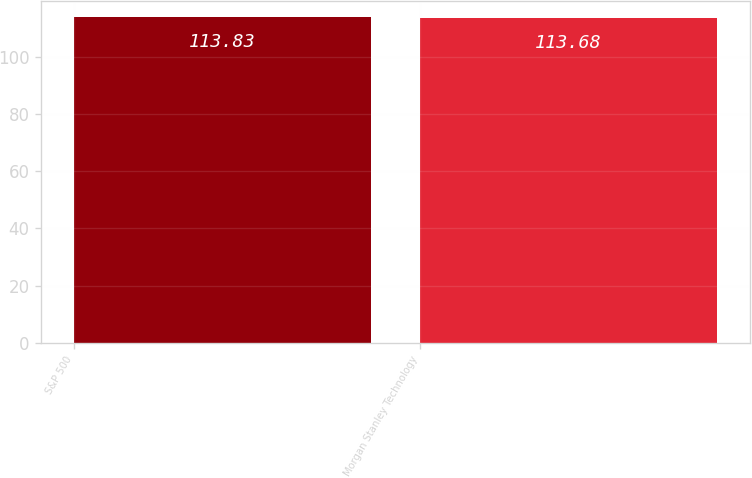<chart> <loc_0><loc_0><loc_500><loc_500><bar_chart><fcel>S&P 500<fcel>Morgan Stanley Technology<nl><fcel>113.83<fcel>113.68<nl></chart> 